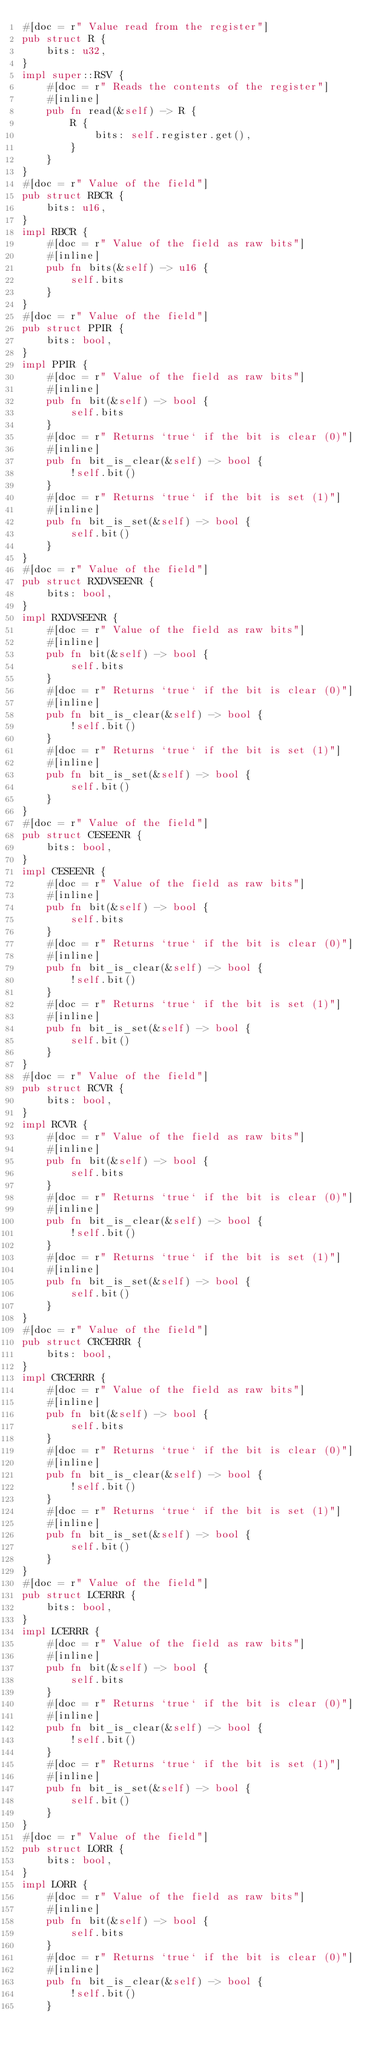<code> <loc_0><loc_0><loc_500><loc_500><_Rust_>#[doc = r" Value read from the register"]
pub struct R {
    bits: u32,
}
impl super::RSV {
    #[doc = r" Reads the contents of the register"]
    #[inline]
    pub fn read(&self) -> R {
        R {
            bits: self.register.get(),
        }
    }
}
#[doc = r" Value of the field"]
pub struct RBCR {
    bits: u16,
}
impl RBCR {
    #[doc = r" Value of the field as raw bits"]
    #[inline]
    pub fn bits(&self) -> u16 {
        self.bits
    }
}
#[doc = r" Value of the field"]
pub struct PPIR {
    bits: bool,
}
impl PPIR {
    #[doc = r" Value of the field as raw bits"]
    #[inline]
    pub fn bit(&self) -> bool {
        self.bits
    }
    #[doc = r" Returns `true` if the bit is clear (0)"]
    #[inline]
    pub fn bit_is_clear(&self) -> bool {
        !self.bit()
    }
    #[doc = r" Returns `true` if the bit is set (1)"]
    #[inline]
    pub fn bit_is_set(&self) -> bool {
        self.bit()
    }
}
#[doc = r" Value of the field"]
pub struct RXDVSEENR {
    bits: bool,
}
impl RXDVSEENR {
    #[doc = r" Value of the field as raw bits"]
    #[inline]
    pub fn bit(&self) -> bool {
        self.bits
    }
    #[doc = r" Returns `true` if the bit is clear (0)"]
    #[inline]
    pub fn bit_is_clear(&self) -> bool {
        !self.bit()
    }
    #[doc = r" Returns `true` if the bit is set (1)"]
    #[inline]
    pub fn bit_is_set(&self) -> bool {
        self.bit()
    }
}
#[doc = r" Value of the field"]
pub struct CESEENR {
    bits: bool,
}
impl CESEENR {
    #[doc = r" Value of the field as raw bits"]
    #[inline]
    pub fn bit(&self) -> bool {
        self.bits
    }
    #[doc = r" Returns `true` if the bit is clear (0)"]
    #[inline]
    pub fn bit_is_clear(&self) -> bool {
        !self.bit()
    }
    #[doc = r" Returns `true` if the bit is set (1)"]
    #[inline]
    pub fn bit_is_set(&self) -> bool {
        self.bit()
    }
}
#[doc = r" Value of the field"]
pub struct RCVR {
    bits: bool,
}
impl RCVR {
    #[doc = r" Value of the field as raw bits"]
    #[inline]
    pub fn bit(&self) -> bool {
        self.bits
    }
    #[doc = r" Returns `true` if the bit is clear (0)"]
    #[inline]
    pub fn bit_is_clear(&self) -> bool {
        !self.bit()
    }
    #[doc = r" Returns `true` if the bit is set (1)"]
    #[inline]
    pub fn bit_is_set(&self) -> bool {
        self.bit()
    }
}
#[doc = r" Value of the field"]
pub struct CRCERRR {
    bits: bool,
}
impl CRCERRR {
    #[doc = r" Value of the field as raw bits"]
    #[inline]
    pub fn bit(&self) -> bool {
        self.bits
    }
    #[doc = r" Returns `true` if the bit is clear (0)"]
    #[inline]
    pub fn bit_is_clear(&self) -> bool {
        !self.bit()
    }
    #[doc = r" Returns `true` if the bit is set (1)"]
    #[inline]
    pub fn bit_is_set(&self) -> bool {
        self.bit()
    }
}
#[doc = r" Value of the field"]
pub struct LCERRR {
    bits: bool,
}
impl LCERRR {
    #[doc = r" Value of the field as raw bits"]
    #[inline]
    pub fn bit(&self) -> bool {
        self.bits
    }
    #[doc = r" Returns `true` if the bit is clear (0)"]
    #[inline]
    pub fn bit_is_clear(&self) -> bool {
        !self.bit()
    }
    #[doc = r" Returns `true` if the bit is set (1)"]
    #[inline]
    pub fn bit_is_set(&self) -> bool {
        self.bit()
    }
}
#[doc = r" Value of the field"]
pub struct LORR {
    bits: bool,
}
impl LORR {
    #[doc = r" Value of the field as raw bits"]
    #[inline]
    pub fn bit(&self) -> bool {
        self.bits
    }
    #[doc = r" Returns `true` if the bit is clear (0)"]
    #[inline]
    pub fn bit_is_clear(&self) -> bool {
        !self.bit()
    }</code> 